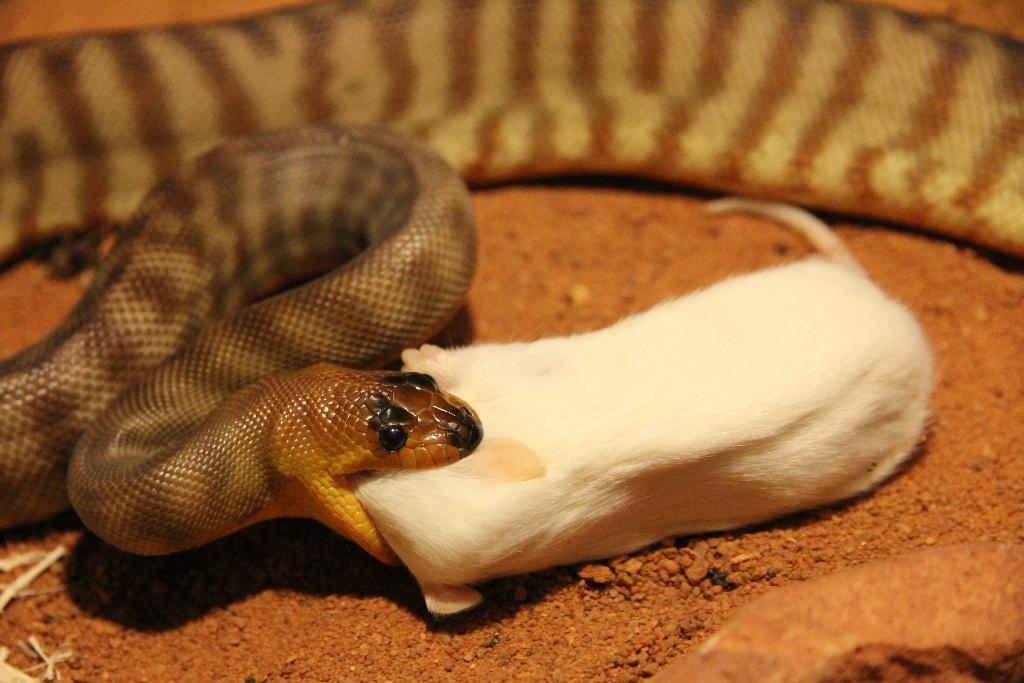What animal can be seen in the image? There is a snake in the image. What colors are present on the snake? The snake is brown, gold, and black in color. What is the snake doing in the image? The snake is biting a rat. What color is the rat in the image? The rat is white in color. What type of surface is visible in the image? There is ground visible in the image. What type of soda is being poured onto the snake in the image? There is no soda present in the image; it features a snake biting a rat on the ground. What part of the snake's body is covered by the umbrella in the image? There is no umbrella present in the image; it only shows a snake, rat, and ground are visible. 